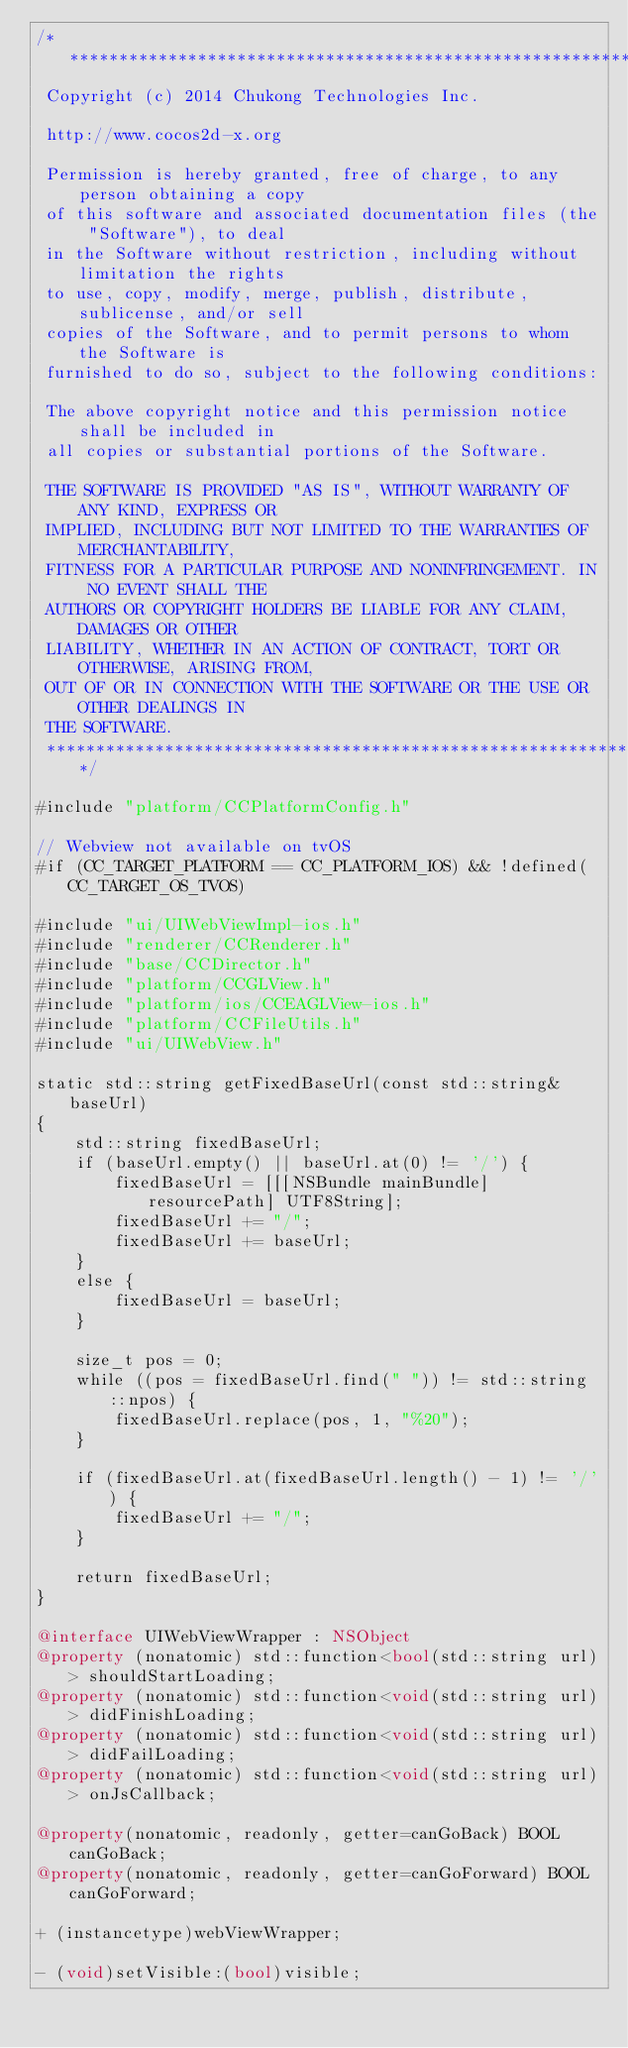<code> <loc_0><loc_0><loc_500><loc_500><_ObjectiveC_>/****************************************************************************
 Copyright (c) 2014 Chukong Technologies Inc.
 
 http://www.cocos2d-x.org
 
 Permission is hereby granted, free of charge, to any person obtaining a copy
 of this software and associated documentation files (the "Software"), to deal
 in the Software without restriction, including without limitation the rights
 to use, copy, modify, merge, publish, distribute, sublicense, and/or sell
 copies of the Software, and to permit persons to whom the Software is
 furnished to do so, subject to the following conditions:
 
 The above copyright notice and this permission notice shall be included in
 all copies or substantial portions of the Software.
 
 THE SOFTWARE IS PROVIDED "AS IS", WITHOUT WARRANTY OF ANY KIND, EXPRESS OR
 IMPLIED, INCLUDING BUT NOT LIMITED TO THE WARRANTIES OF MERCHANTABILITY,
 FITNESS FOR A PARTICULAR PURPOSE AND NONINFRINGEMENT. IN NO EVENT SHALL THE
 AUTHORS OR COPYRIGHT HOLDERS BE LIABLE FOR ANY CLAIM, DAMAGES OR OTHER
 LIABILITY, WHETHER IN AN ACTION OF CONTRACT, TORT OR OTHERWISE, ARISING FROM,
 OUT OF OR IN CONNECTION WITH THE SOFTWARE OR THE USE OR OTHER DEALINGS IN
 THE SOFTWARE.
 ****************************************************************************/

#include "platform/CCPlatformConfig.h"

// Webview not available on tvOS
#if (CC_TARGET_PLATFORM == CC_PLATFORM_IOS) && !defined(CC_TARGET_OS_TVOS)

#include "ui/UIWebViewImpl-ios.h"
#include "renderer/CCRenderer.h"
#include "base/CCDirector.h"
#include "platform/CCGLView.h"
#include "platform/ios/CCEAGLView-ios.h"
#include "platform/CCFileUtils.h"
#include "ui/UIWebView.h"

static std::string getFixedBaseUrl(const std::string& baseUrl)
{
    std::string fixedBaseUrl;
    if (baseUrl.empty() || baseUrl.at(0) != '/') {
        fixedBaseUrl = [[[NSBundle mainBundle] resourcePath] UTF8String];
        fixedBaseUrl += "/";
        fixedBaseUrl += baseUrl;
    }
    else {
        fixedBaseUrl = baseUrl;
    }
    
    size_t pos = 0;
    while ((pos = fixedBaseUrl.find(" ")) != std::string::npos) {
        fixedBaseUrl.replace(pos, 1, "%20");
    }
    
    if (fixedBaseUrl.at(fixedBaseUrl.length() - 1) != '/') {
        fixedBaseUrl += "/";
    }
    
    return fixedBaseUrl;
}

@interface UIWebViewWrapper : NSObject
@property (nonatomic) std::function<bool(std::string url)> shouldStartLoading;
@property (nonatomic) std::function<void(std::string url)> didFinishLoading;
@property (nonatomic) std::function<void(std::string url)> didFailLoading;
@property (nonatomic) std::function<void(std::string url)> onJsCallback;

@property(nonatomic, readonly, getter=canGoBack) BOOL canGoBack;
@property(nonatomic, readonly, getter=canGoForward) BOOL canGoForward;

+ (instancetype)webViewWrapper;

- (void)setVisible:(bool)visible;
</code> 